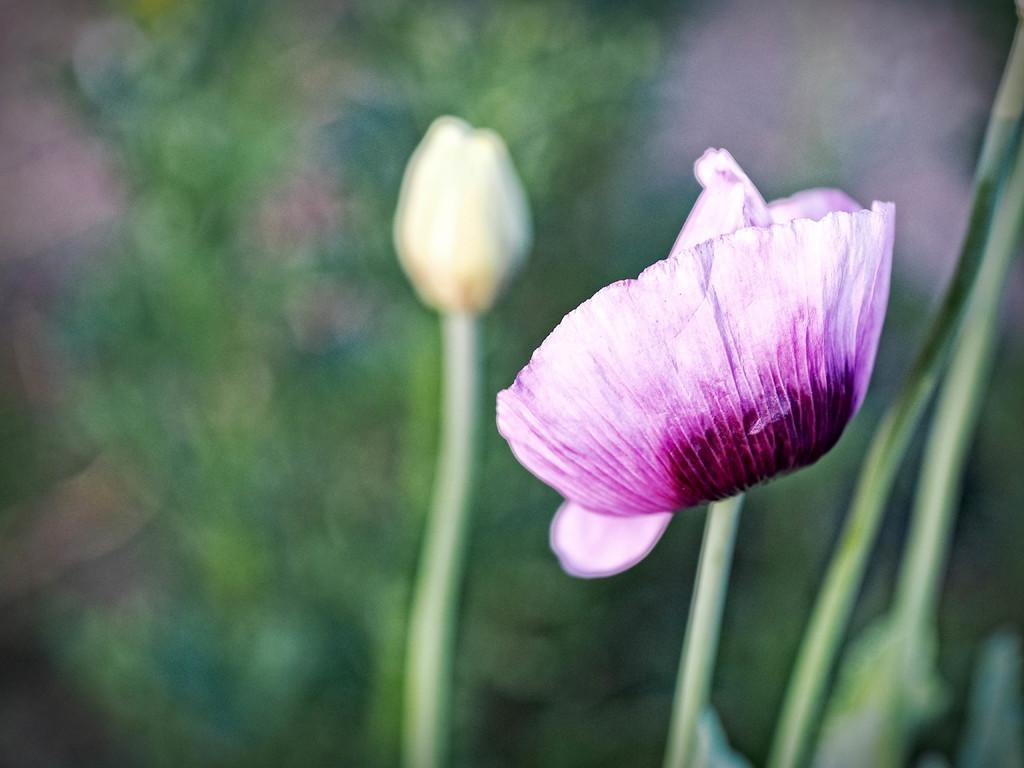What type of living organisms can be seen in the image? There are flowers in the image. Can you describe the background of the image? The background of the image is blurred. What type of powder is being used during the feast in the image? There is no feast or powder present in the image; it features flowers and a blurred background. 